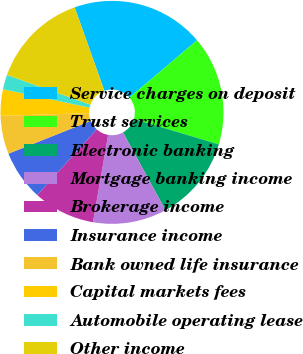Convert chart to OTSL. <chart><loc_0><loc_0><loc_500><loc_500><pie_chart><fcel>Service charges on deposit<fcel>Trust services<fcel>Electronic banking<fcel>Mortgage banking income<fcel>Brokerage income<fcel>Insurance income<fcel>Bank owned life insurance<fcel>Capital markets fees<fcel>Automobile operating lease<fcel>Other income<nl><fcel>19.25%<fcel>15.83%<fcel>12.4%<fcel>10.69%<fcel>8.97%<fcel>7.26%<fcel>5.54%<fcel>3.83%<fcel>2.12%<fcel>14.11%<nl></chart> 